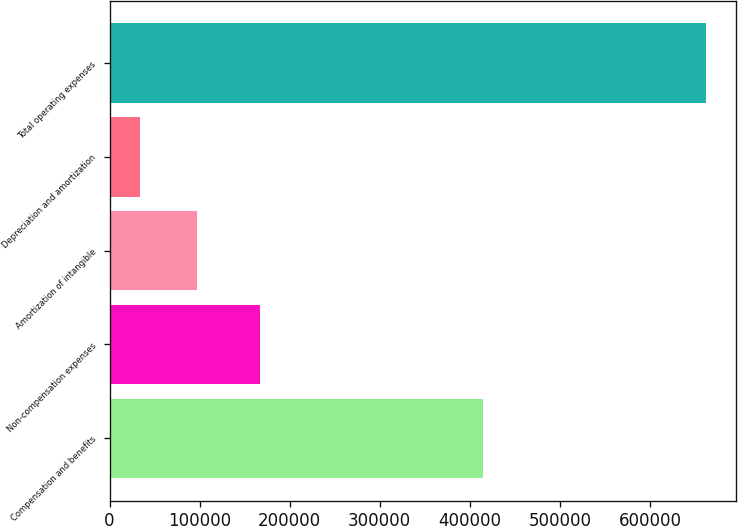<chart> <loc_0><loc_0><loc_500><loc_500><bar_chart><fcel>Compensation and benefits<fcel>Non-compensation expenses<fcel>Amortization of intangible<fcel>Depreciation and amortization<fcel>Total operating expenses<nl><fcel>414322<fcel>166890<fcel>97144.5<fcel>34320<fcel>662565<nl></chart> 